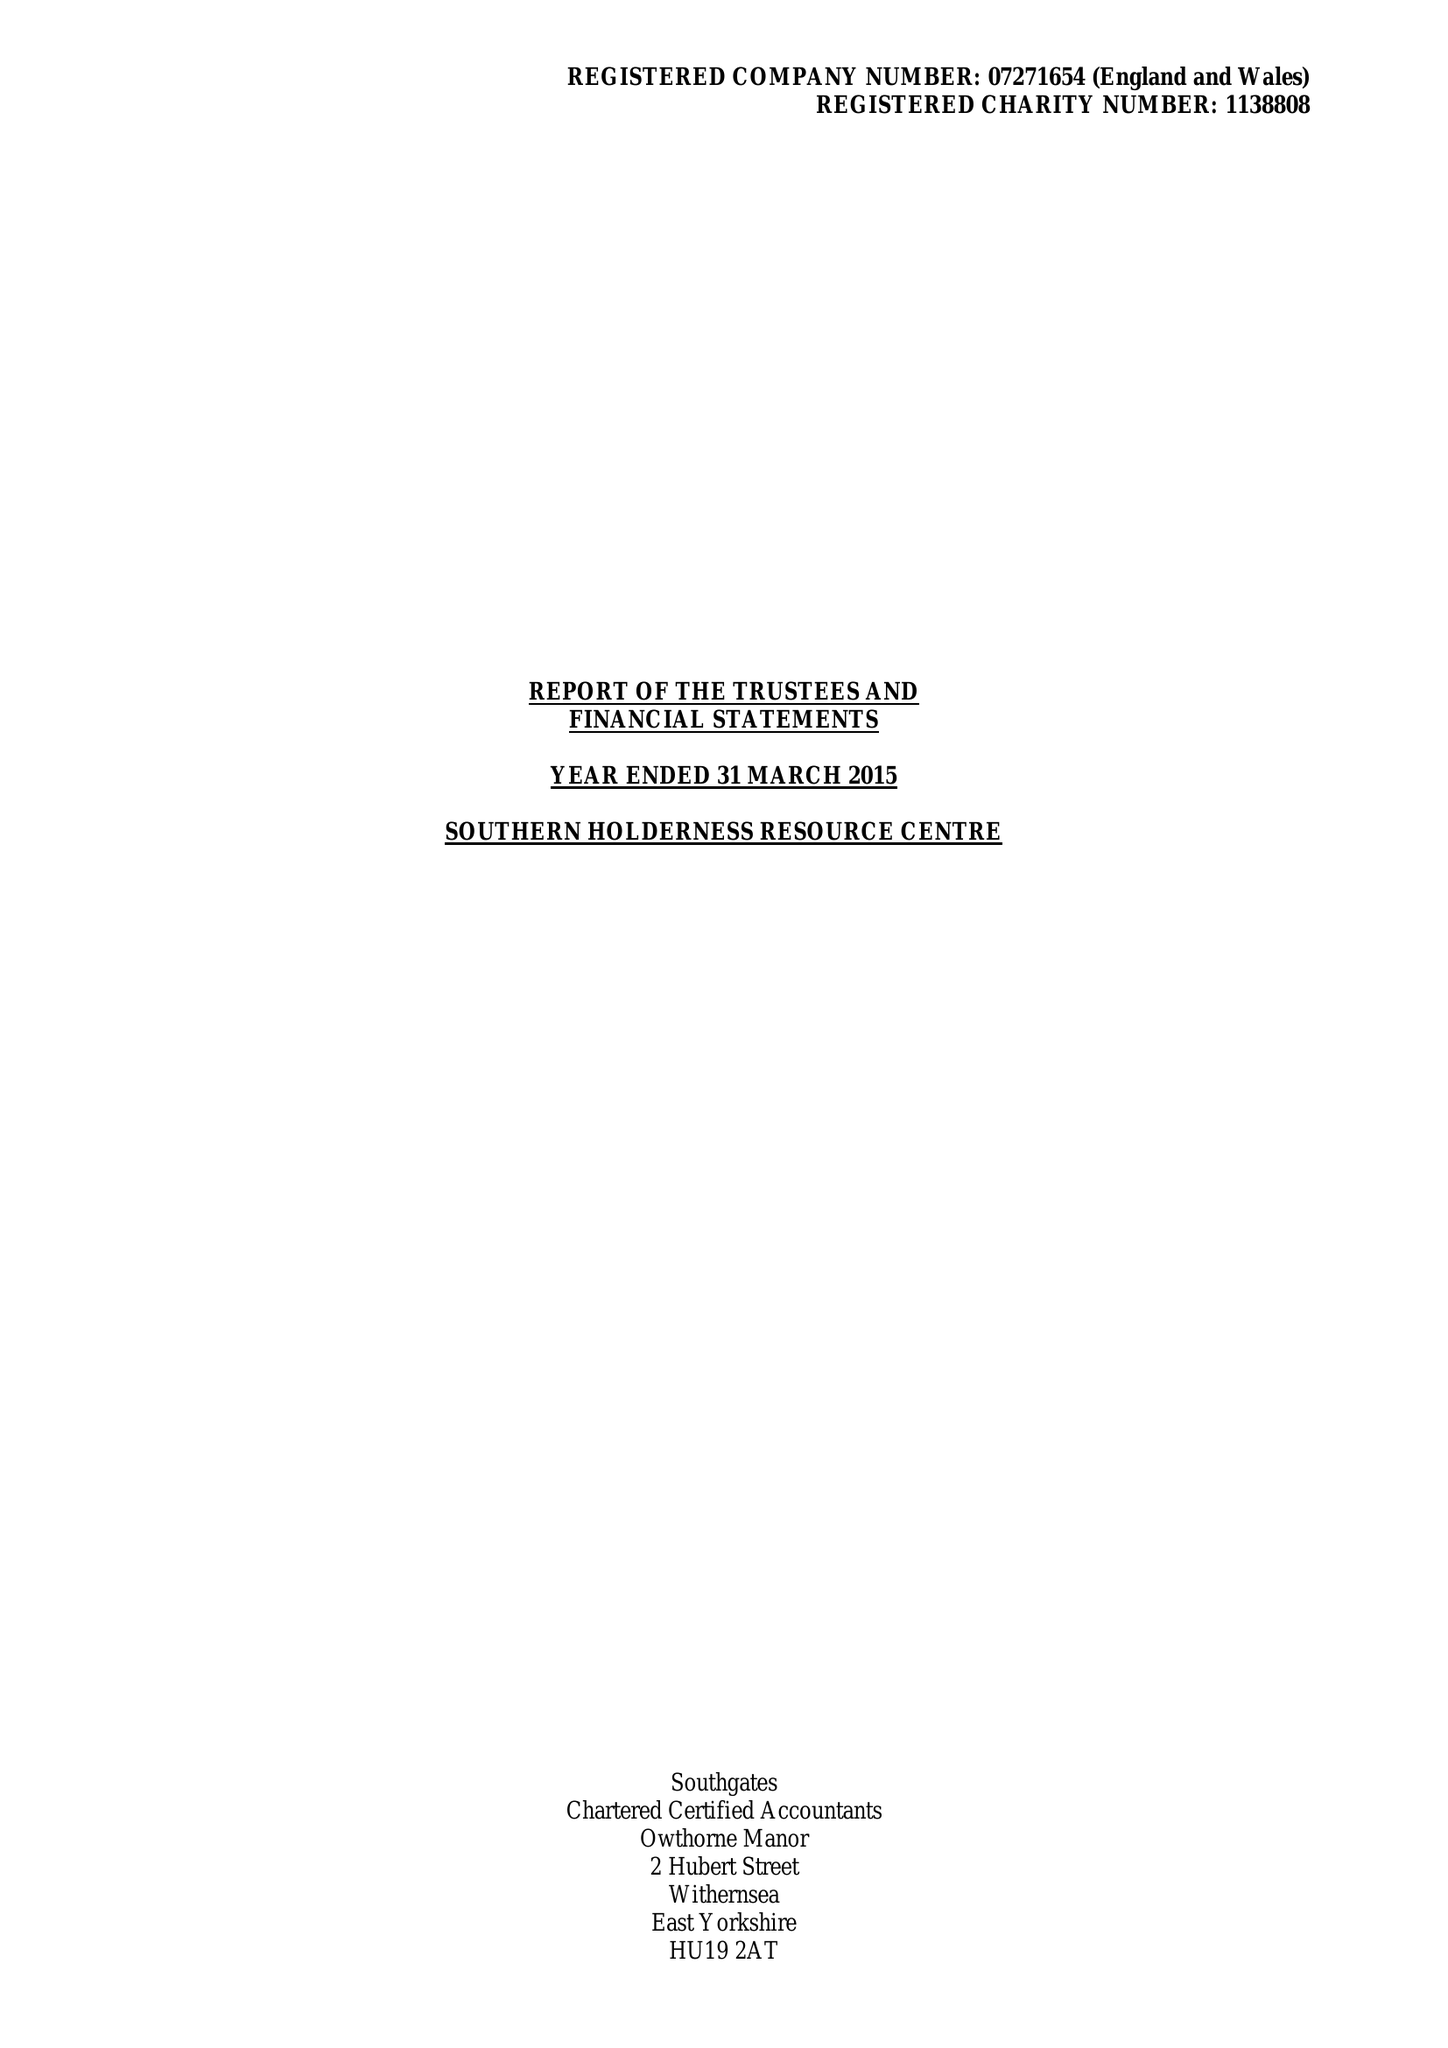What is the value for the address__postcode?
Answer the question using a single word or phrase. HU19 2DL 